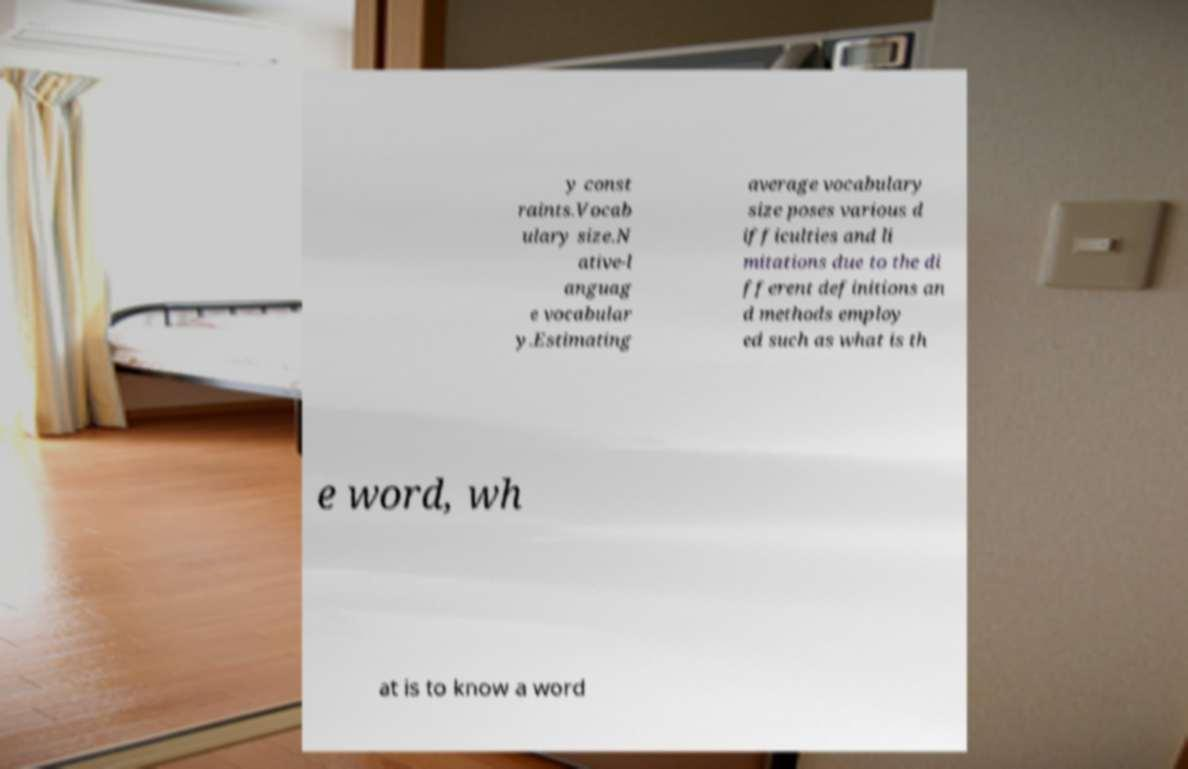Can you accurately transcribe the text from the provided image for me? y const raints.Vocab ulary size.N ative-l anguag e vocabular y.Estimating average vocabulary size poses various d ifficulties and li mitations due to the di fferent definitions an d methods employ ed such as what is th e word, wh at is to know a word 